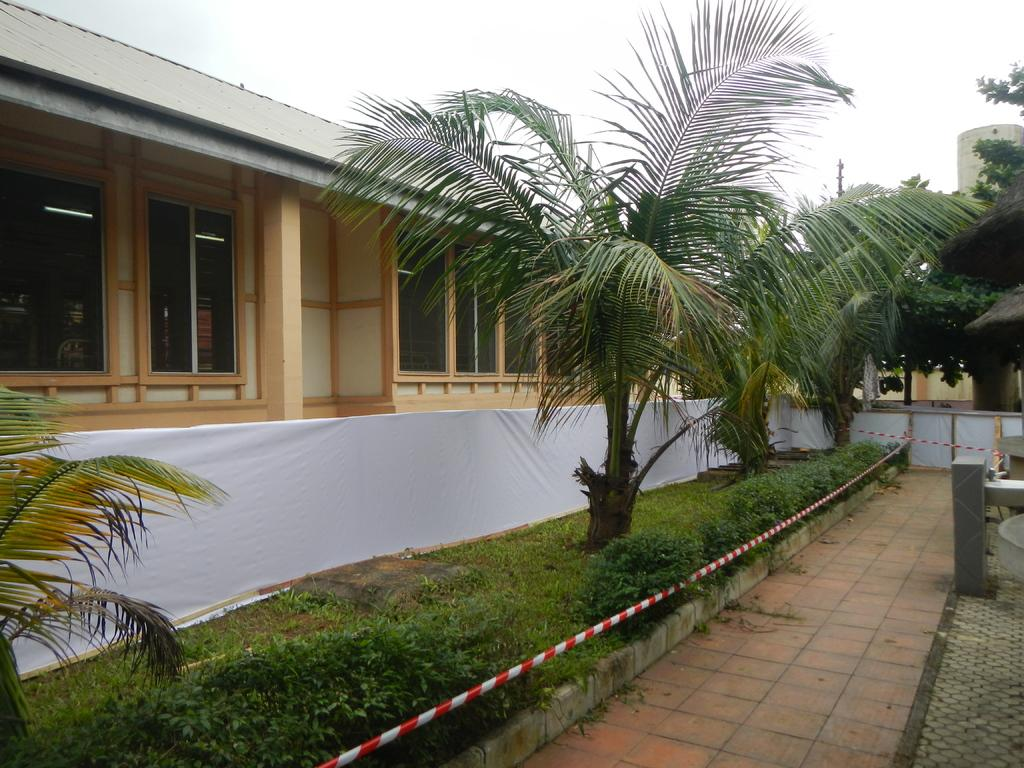What type of vegetation is on the right side of the image? There are trees on the right side of the image. What type of structure is on the left side of the image? There is a building on the left side of the image. What is visible in the background of the image? The sky is visible in the background of the image. How does the mind interact with the trees in the image? There is no indication of a mind or any mental activity in the image; it only features trees and a building. What type of root is visible in the image? There is no root visible in the image; it only features trees and a building. 